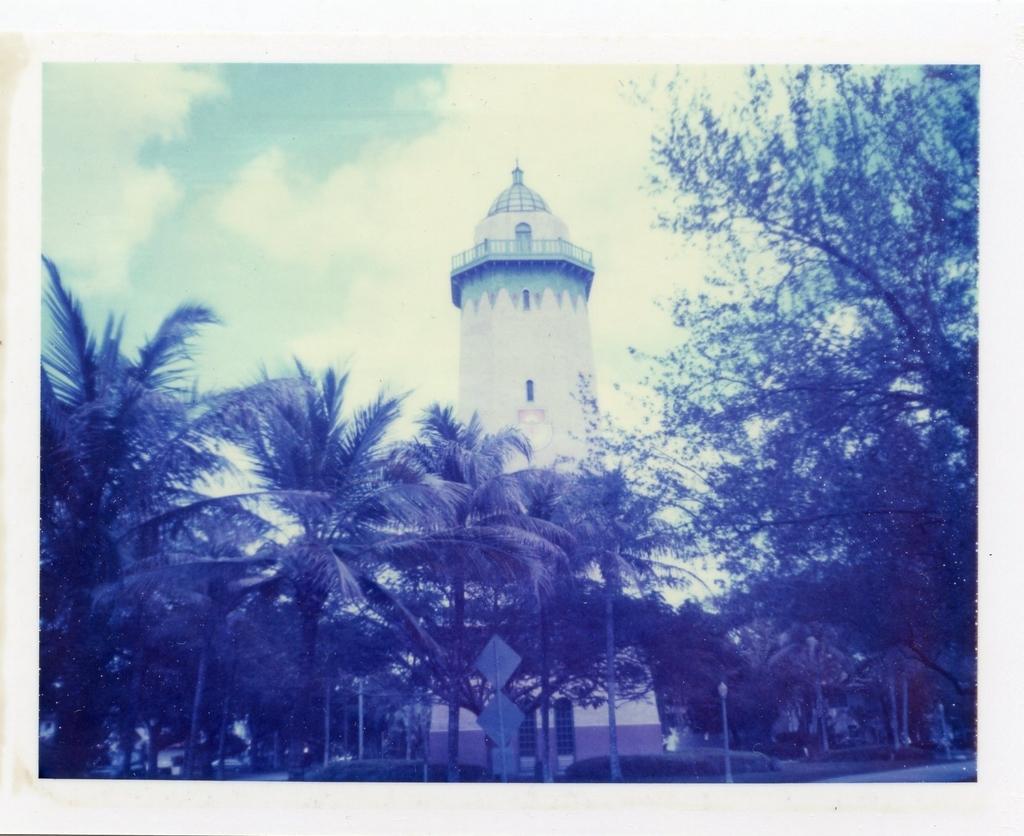In one or two sentences, can you explain what this image depicts? In this picture I can see a photo. There is a building, there are poles, boards, there are trees, and in the background there is the sky. 